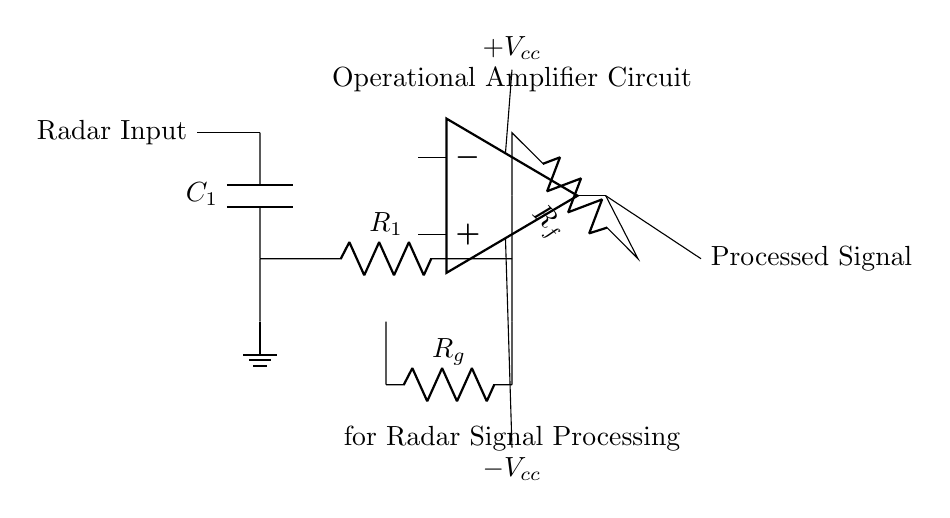What type of components are used in this circuit? The circuit includes capacitors (C), resistors (R), and an operational amplifier (op amp). These are common components found in analog signal processing circuits.
Answer: Capacitor, Resistor, Operational Amplifier What is the purpose of the capacitor in the circuit? The capacitor (C1) is likely used for coupling or filtering signals, which helps to block DC components while allowing AC signals (like radar signals) to pass through.
Answer: Coupling or filtering What does the feedback resistor Rf do in this circuit? The feedback resistor (Rf) sets the gain of the operational amplifier, influencing how much the output signal is amplified based on the input signal.
Answer: Sets gain What is the role of the gain resistor Rg in the circuit? Resistor Rg works in conjunction with Rf to determine the overall gain of the operational amplifier circuit. This configuration specifically helps in fine-tuning the gain of the processed radar signals.
Answer: Fine-tunes gain How many power supply connections are there for the operational amplifier? The operational amplifier has two power supply connections: a positive voltage ($+V_{cc}$) and a negative voltage ($-V_{cc}$). These are essential for the op amp to function correctly.
Answer: Two What is the significance of grounding in this circuit? Grounding provides a reference point for the circuit voltages, ensuring stable operation of the components and safety in case of faults, which is critical in radar applications.
Answer: Reference point for voltages How does the input signal interact with the operational amplifier? The input signal enters the operational amplifier through its inverting or non-inverting terminal, where it gets amplified based on the feedback network formed by the resistors Rf and Rg.
Answer: Amplified by feedback network 